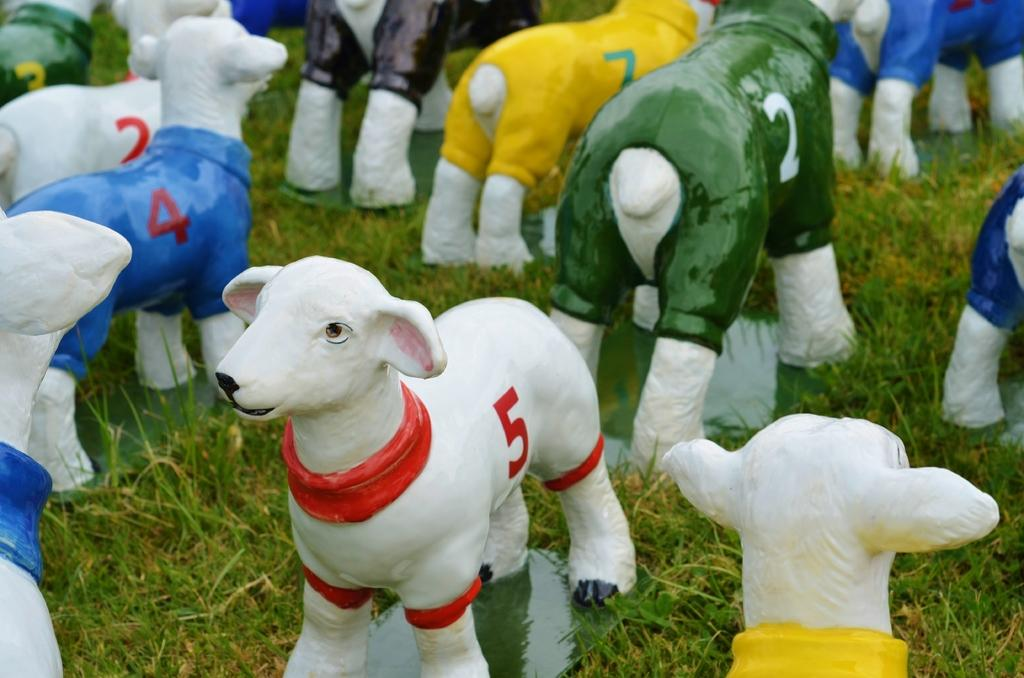What is the main subject in the center of the image? There are sheep statues in the center of the image. What are the sheep statues wearing? The sheep statues have dresses. Are there any distinguishing features on the sheep statues? Yes, the sheep statues have numbers on them. What type of natural environment is visible in the image? There is grass visible in the image. How fast are the sheep statues running in the image? The sheep statues are not running in the image, as they are statues and not capable of movement. 